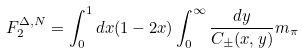Convert formula to latex. <formula><loc_0><loc_0><loc_500><loc_500>F _ { 2 } ^ { \Delta , N } = \int _ { 0 } ^ { 1 } d x ( 1 - 2 x ) \int _ { 0 } ^ { \infty } { \frac { d y } { C _ { \pm } ( x , y ) } } m _ { \pi }</formula> 